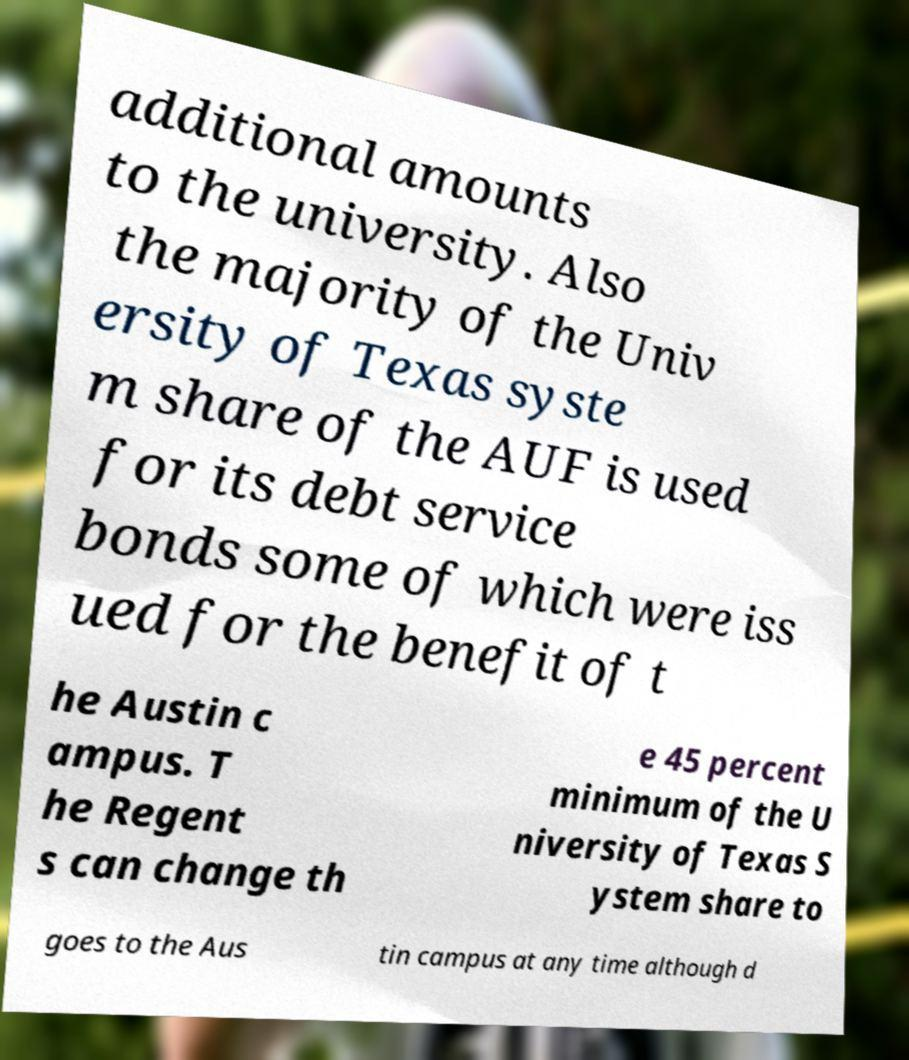What messages or text are displayed in this image? I need them in a readable, typed format. additional amounts to the university. Also the majority of the Univ ersity of Texas syste m share of the AUF is used for its debt service bonds some of which were iss ued for the benefit of t he Austin c ampus. T he Regent s can change th e 45 percent minimum of the U niversity of Texas S ystem share to goes to the Aus tin campus at any time although d 